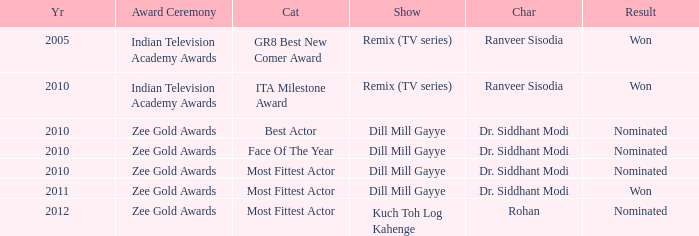Which character was nominated in the 2010 Indian Television Academy Awards? Ranveer Sisodia. 